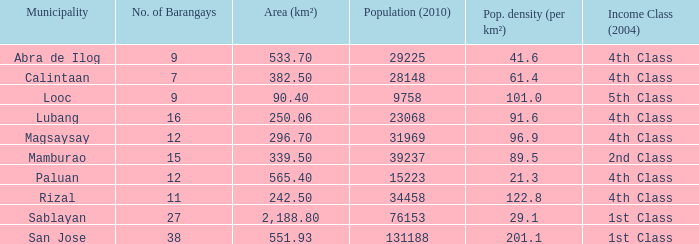What is the population density for the city of lubang? 1.0. 